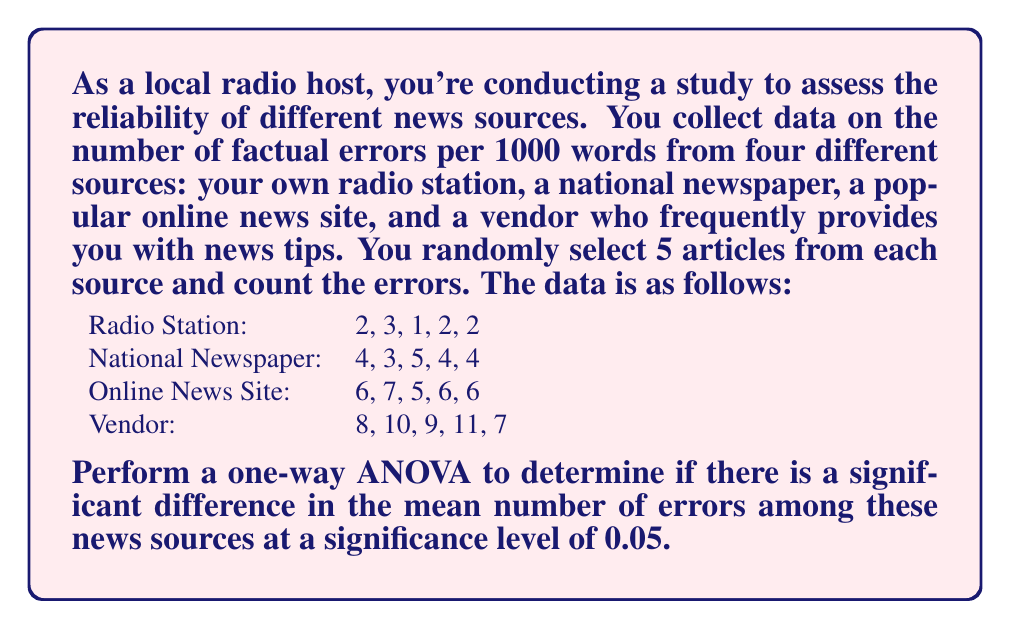Could you help me with this problem? To perform a one-way ANOVA, we'll follow these steps:

1. Calculate the sum of squares between groups (SSB) and within groups (SSW).
2. Calculate the degrees of freedom for between groups (dfB) and within groups (dfW).
3. Calculate the mean square between groups (MSB) and within groups (MSW).
4. Calculate the F-statistic.
5. Compare the F-statistic to the critical F-value.

Step 1: Calculate SSB and SSW

First, we need to calculate the grand mean and group means:

Grand mean = $\frac{(2+3+1+2+2) + (4+3+5+4+4) + (6+7+5+6+6) + (8+10+9+11+7)}{20} = 5.25$

Group means:
Radio Station: $\bar{x}_1 = 2$
National Newspaper: $\bar{x}_2 = 4$
Online News Site: $\bar{x}_3 = 6$
Vendor: $\bar{x}_4 = 9$

SSB = $\sum_{i=1}^k n_i(\bar{x}_i - \bar{x})^2$
    = $5(2-5.25)^2 + 5(4-5.25)^2 + 5(6-5.25)^2 + 5(9-5.25)^2$
    = $5((-3.25)^2 + (-1.25)^2 + 0.75^2 + 3.75^2)$
    = $5(10.5625 + 1.5625 + 0.5625 + 14.0625)$
    = $5(26.75) = 133.75$

SSW = $\sum_{i=1}^k \sum_{j=1}^{n_i} (x_{ij} - \bar{x}_i)^2$
    = $((2-2)^2 + (3-2)^2 + (1-2)^2 + (2-2)^2 + (2-2)^2)$
    + $((4-4)^2 + (3-4)^2 + (5-4)^2 + (4-4)^2 + (4-4)^2)$
    + $((6-6)^2 + (7-6)^2 + (5-6)^2 + (6-6)^2 + (6-6)^2)$
    + $((8-9)^2 + (10-9)^2 + (9-9)^2 + (11-9)^2 + (7-9)^2)$
    = $(0 + 1 + 1 + 0 + 0) + (0 + 1 + 1 + 0 + 0) + (0 + 1 + 1 + 0 + 0) + (1 + 1 + 0 + 4 + 4)$
    = $2 + 2 + 2 + 10 = 16$

Step 2: Calculate degrees of freedom

dfB = k - 1 = 4 - 1 = 3
dfW = N - k = 20 - 4 = 16

Step 3: Calculate MSB and MSW

MSB = SSB / dfB = 133.75 / 3 = 44.58
MSW = SSW / dfW = 16 / 16 = 1

Step 4: Calculate F-statistic

F = MSB / MSW = 44.58 / 1 = 44.58

Step 5: Compare F-statistic to critical F-value

The critical F-value for α = 0.05, dfB = 3, and dfW = 16 is approximately 3.24.

Since our calculated F-statistic (44.58) is greater than the critical F-value (3.24), we reject the null hypothesis.
Answer: The one-way ANOVA results in an F-statistic of 44.58, which is greater than the critical F-value of 3.24 at α = 0.05. Therefore, we reject the null hypothesis and conclude that there is a significant difference in the mean number of errors among the different news sources. 